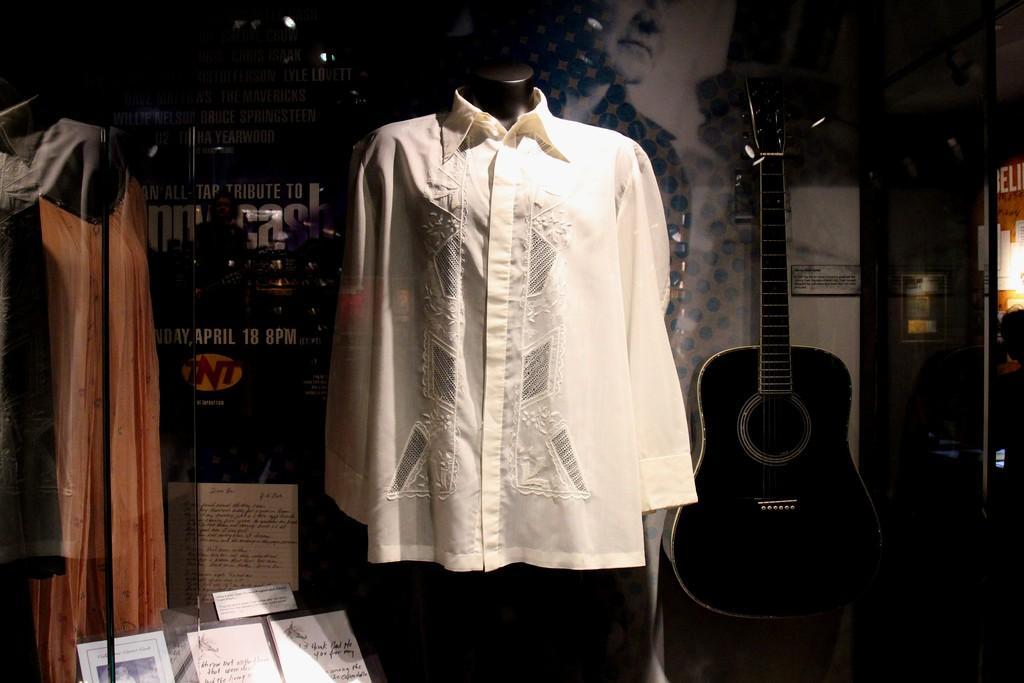Could you give a brief overview of what you see in this image? Here we can see a shirt in the middle and at the right side we can see a guitar placed on a table and at the left side again we can see a dress 